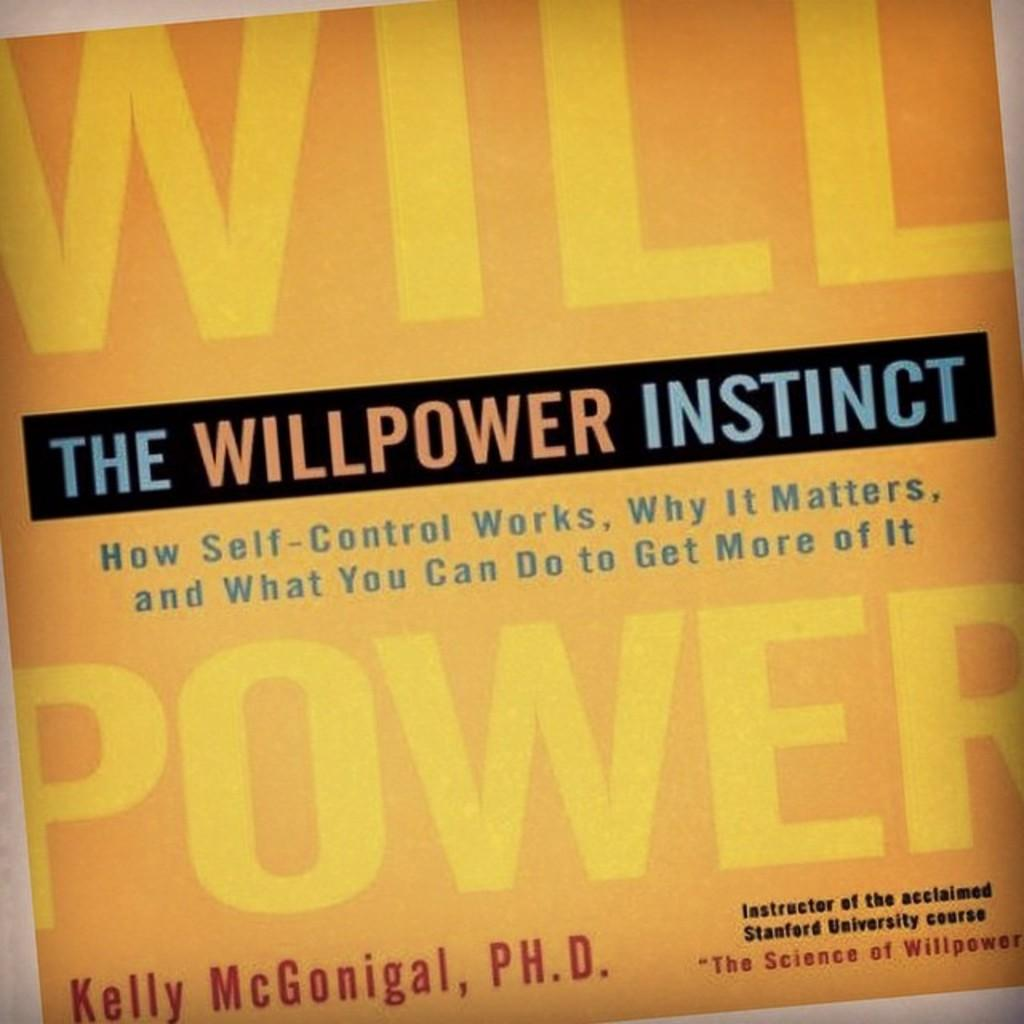<image>
Describe the image concisely. Kelly McGonigal is the author of The Willpower Instinct, a book about self-control 